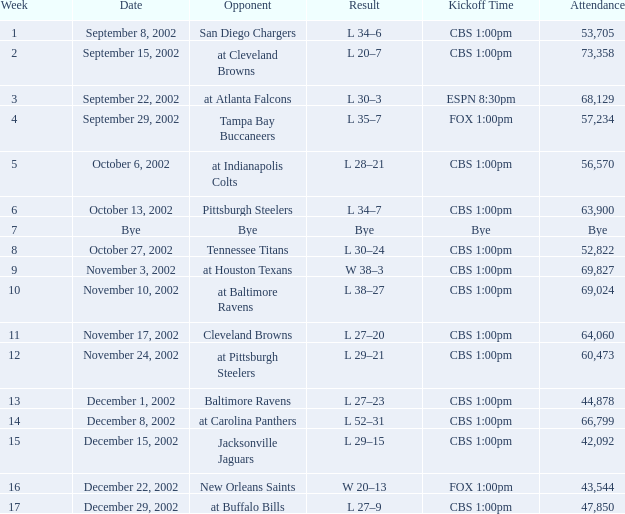What week number was the kickoff time cbs 1:00pm, with 60,473 people in attendance? 1.0. 